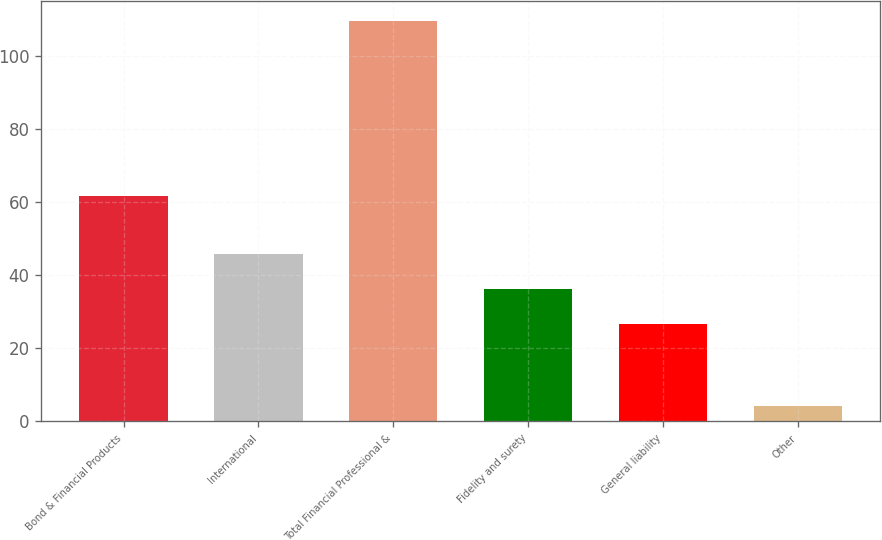Convert chart to OTSL. <chart><loc_0><loc_0><loc_500><loc_500><bar_chart><fcel>Bond & Financial Products<fcel>International<fcel>Total Financial Professional &<fcel>Fidelity and surety<fcel>General liability<fcel>Other<nl><fcel>61.7<fcel>45.66<fcel>109.58<fcel>36.08<fcel>26.5<fcel>4.2<nl></chart> 